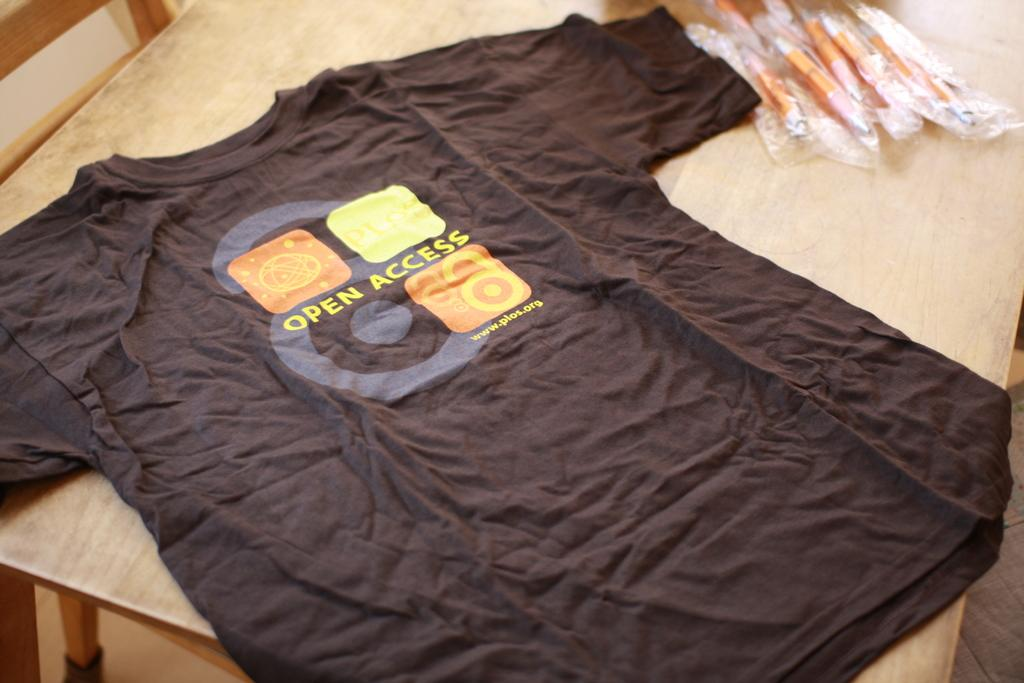What item is placed on the table in the image? There is a t-shirt placed on a table in the image. What is written on the t-shirt? The t-shirt has "open lexus" written on it. What else can be seen in the image besides the t-shirt? There are pens packed in a cover to the right side of the image. What type of amusement can be seen in the image? There is no amusement present in the image; it features a t-shirt and pens packed in a cover. What type of apparel is being ironed in the image? There is no ironing or apparel being ironed in the image; it only shows a t-shirt placed on a table and pens packed in a cover. 